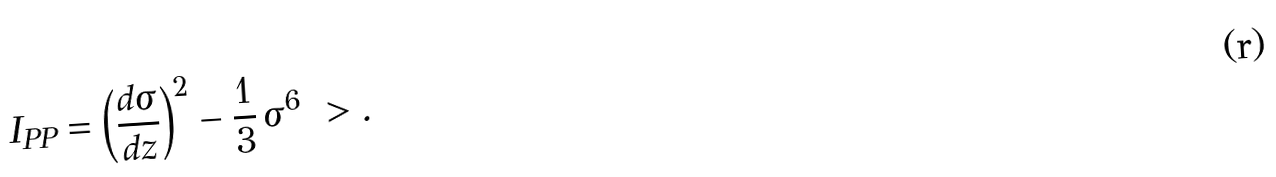<formula> <loc_0><loc_0><loc_500><loc_500>I _ { P P } = \left ( \frac { d \sigma } { d z } \right ) ^ { 2 } - \frac { 1 } { 3 } \, \sigma ^ { 6 } \ > .</formula> 